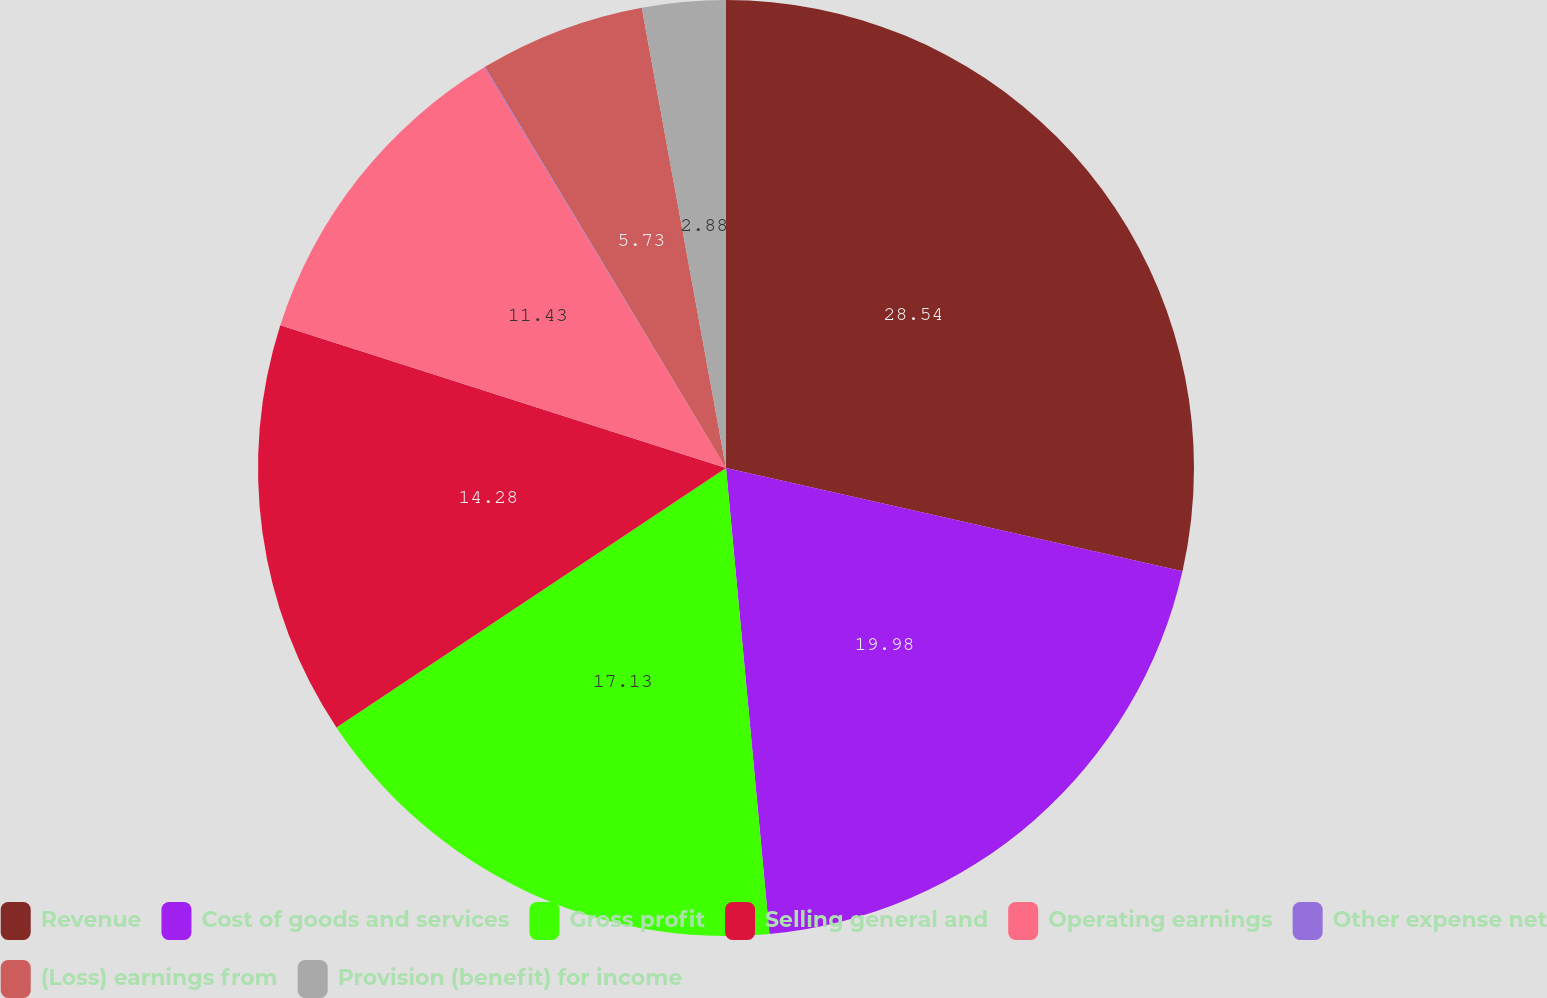Convert chart to OTSL. <chart><loc_0><loc_0><loc_500><loc_500><pie_chart><fcel>Revenue<fcel>Cost of goods and services<fcel>Gross profit<fcel>Selling general and<fcel>Operating earnings<fcel>Other expense net<fcel>(Loss) earnings from<fcel>Provision (benefit) for income<nl><fcel>28.54%<fcel>19.98%<fcel>17.13%<fcel>14.28%<fcel>11.43%<fcel>0.03%<fcel>5.73%<fcel>2.88%<nl></chart> 